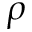<formula> <loc_0><loc_0><loc_500><loc_500>\rho</formula> 